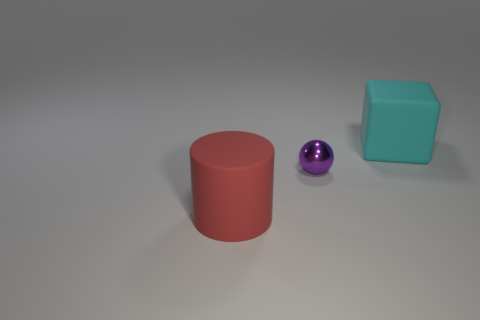Is there any other thing that has the same size as the cylinder?
Make the answer very short. Yes. Are there more red matte cylinders than big things?
Ensure brevity in your answer.  No. There is a tiny object that is in front of the rubber object that is behind the large red cylinder; what is it made of?
Your answer should be very brief. Metal. Do the ball and the block have the same size?
Offer a very short reply. No. There is a thing that is behind the purple sphere; is there a large thing left of it?
Offer a terse response. Yes. There is a big matte thing behind the red cylinder; what shape is it?
Keep it short and to the point. Cube. How many small balls are in front of the big thing that is in front of the matte thing that is behind the purple object?
Keep it short and to the point. 0. There is a rubber cylinder; does it have the same size as the purple thing that is on the right side of the large rubber cylinder?
Provide a short and direct response. No. There is a matte object that is in front of the object right of the purple object; what size is it?
Keep it short and to the point. Large. What number of cyan cubes have the same material as the red cylinder?
Provide a succinct answer. 1. 